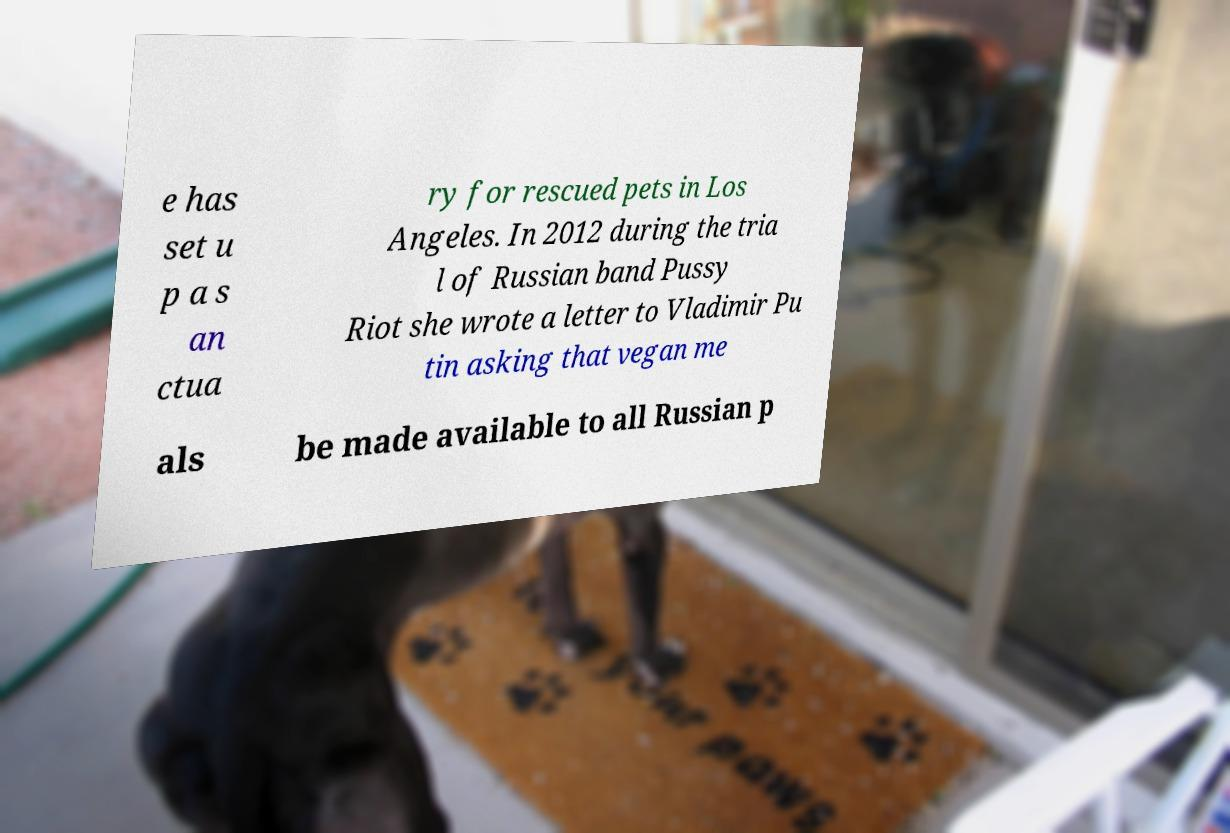I need the written content from this picture converted into text. Can you do that? e has set u p a s an ctua ry for rescued pets in Los Angeles. In 2012 during the tria l of Russian band Pussy Riot she wrote a letter to Vladimir Pu tin asking that vegan me als be made available to all Russian p 